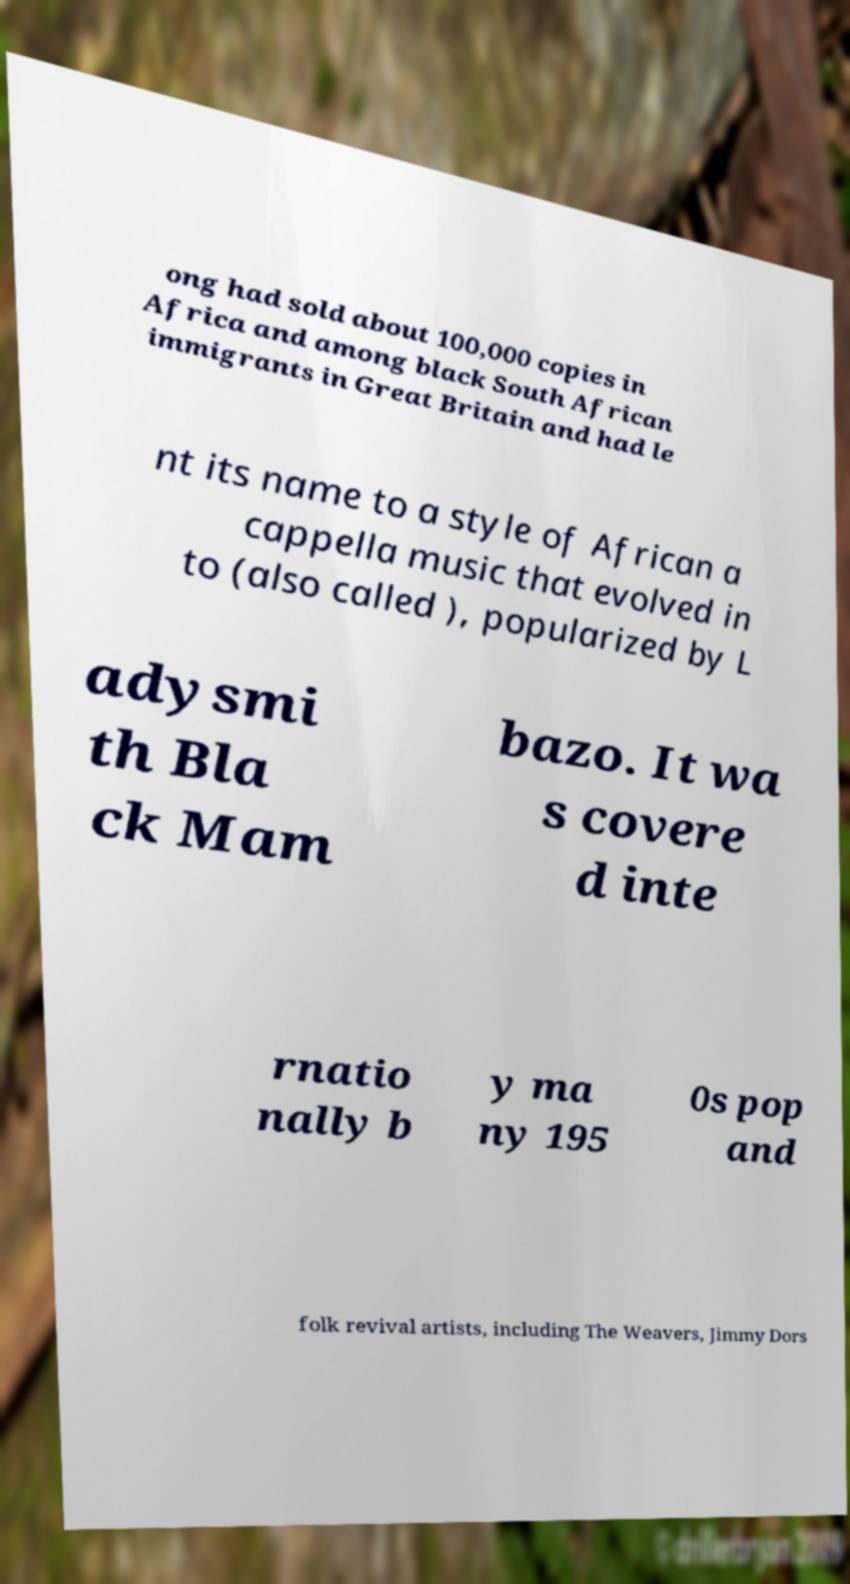For documentation purposes, I need the text within this image transcribed. Could you provide that? ong had sold about 100,000 copies in Africa and among black South African immigrants in Great Britain and had le nt its name to a style of African a cappella music that evolved in to (also called ), popularized by L adysmi th Bla ck Mam bazo. It wa s covere d inte rnatio nally b y ma ny 195 0s pop and folk revival artists, including The Weavers, Jimmy Dors 